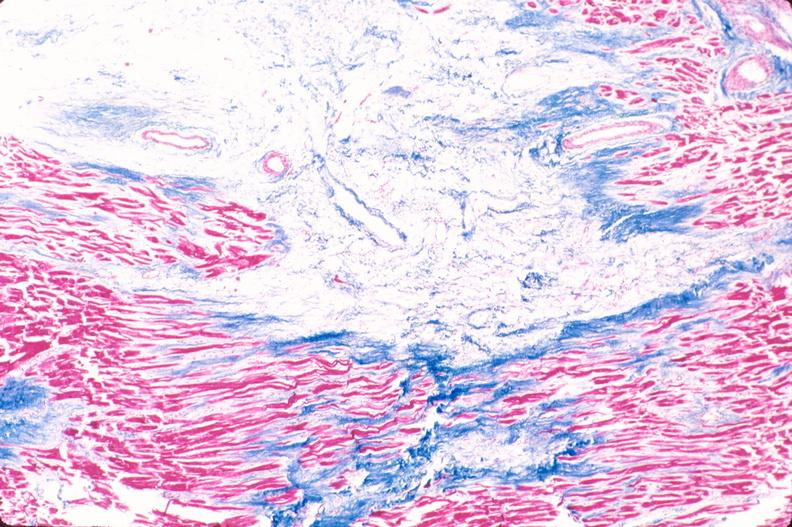what is present?
Answer the question using a single word or phrase. Cardiovascular 